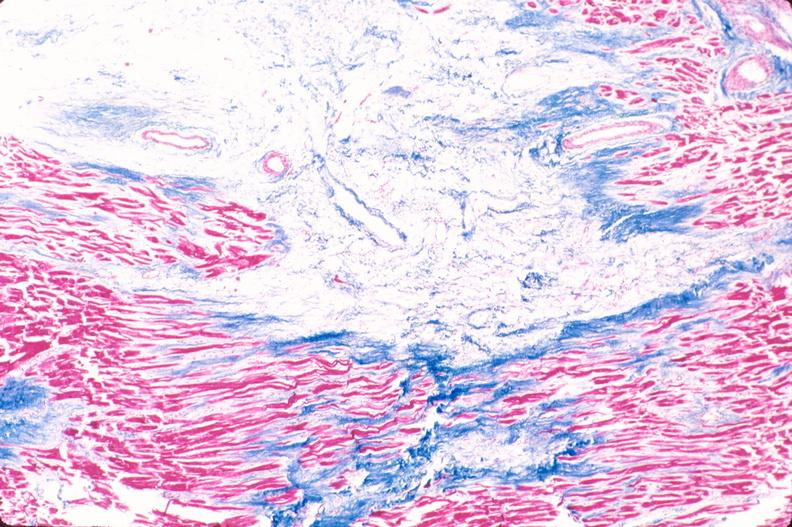what is present?
Answer the question using a single word or phrase. Cardiovascular 